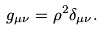<formula> <loc_0><loc_0><loc_500><loc_500>g _ { \mu \nu } = \rho ^ { 2 } \delta _ { \mu \nu } .</formula> 